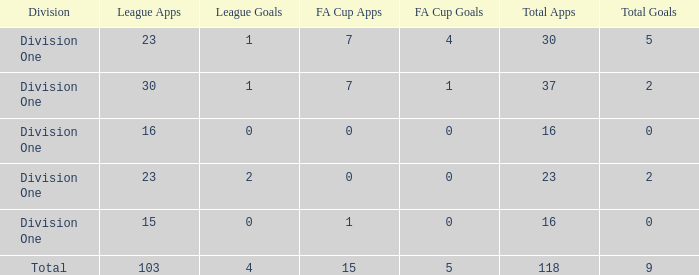It has a FA Cup Goals smaller than 4, and a FA Cup Apps larger than 7, what is the total number of total apps? 0.0. 